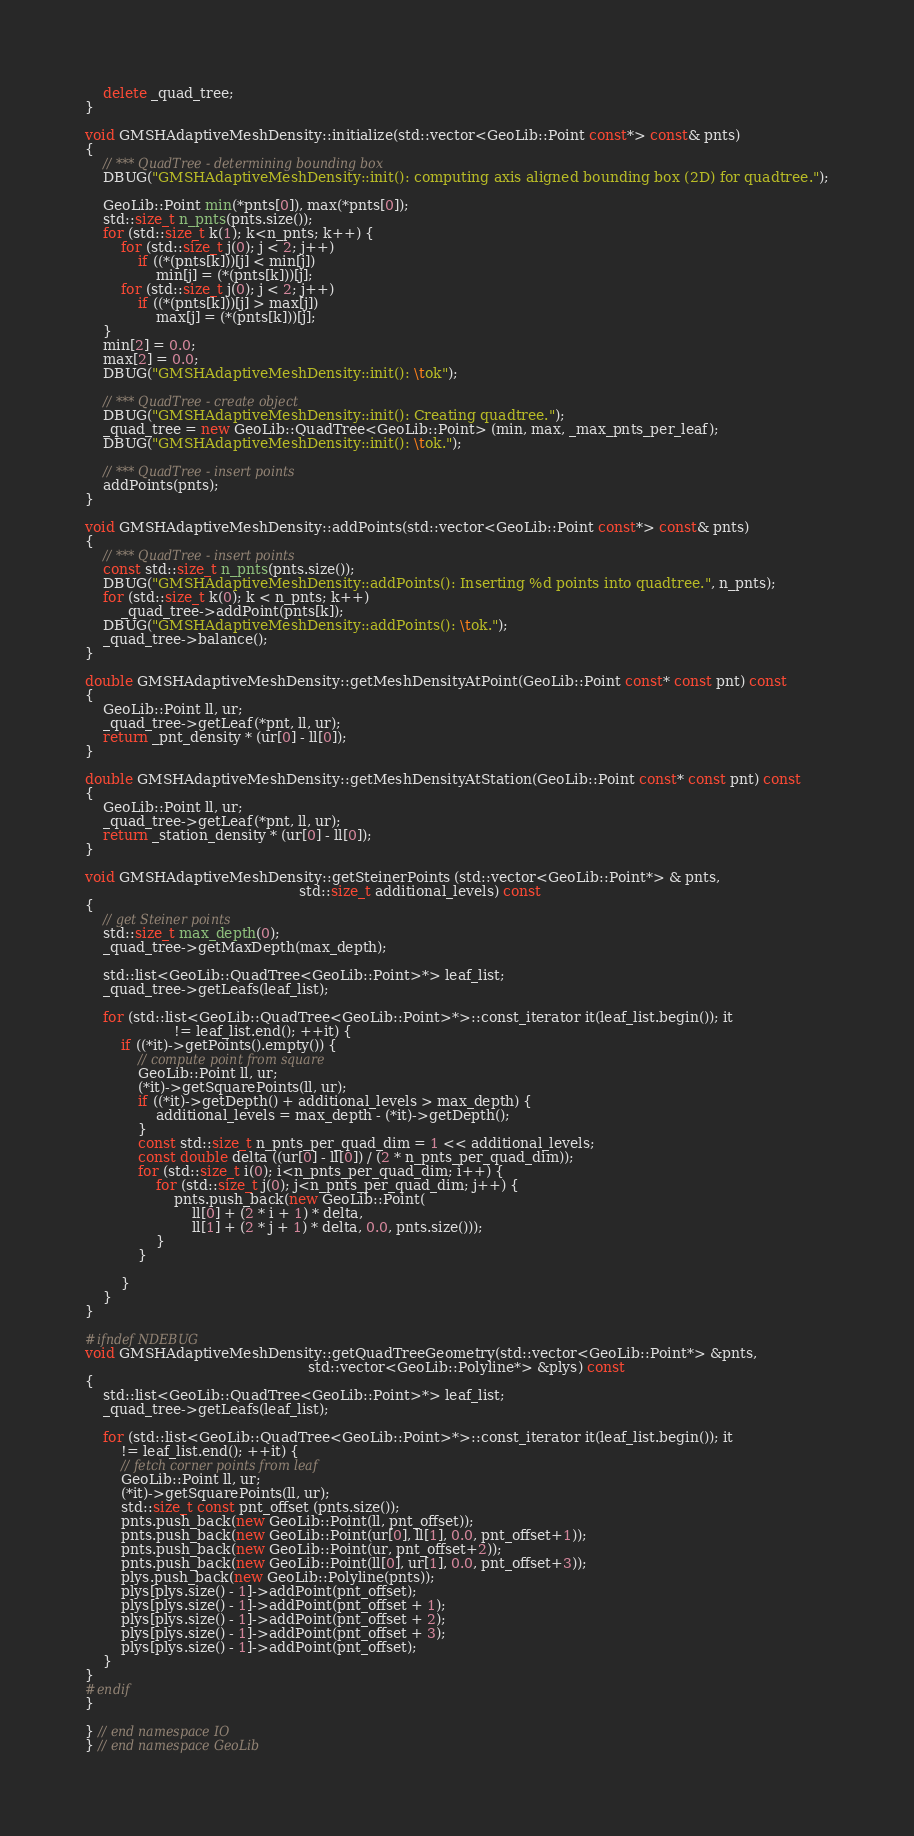Convert code to text. <code><loc_0><loc_0><loc_500><loc_500><_C++_>    delete _quad_tree;
}

void GMSHAdaptiveMeshDensity::initialize(std::vector<GeoLib::Point const*> const& pnts)
{
    // *** QuadTree - determining bounding box
    DBUG("GMSHAdaptiveMeshDensity::init(): computing axis aligned bounding box (2D) for quadtree.");

    GeoLib::Point min(*pnts[0]), max(*pnts[0]);
    std::size_t n_pnts(pnts.size());
    for (std::size_t k(1); k<n_pnts; k++) {
        for (std::size_t j(0); j < 2; j++)
            if ((*(pnts[k]))[j] < min[j])
                min[j] = (*(pnts[k]))[j];
        for (std::size_t j(0); j < 2; j++)
            if ((*(pnts[k]))[j] > max[j])
                max[j] = (*(pnts[k]))[j];
    }
    min[2] = 0.0;
    max[2] = 0.0;
    DBUG("GMSHAdaptiveMeshDensity::init(): \tok");

    // *** QuadTree - create object
    DBUG("GMSHAdaptiveMeshDensity::init(): Creating quadtree.");
    _quad_tree = new GeoLib::QuadTree<GeoLib::Point> (min, max, _max_pnts_per_leaf);
    DBUG("GMSHAdaptiveMeshDensity::init(): \tok.");

    // *** QuadTree - insert points
    addPoints(pnts);
}

void GMSHAdaptiveMeshDensity::addPoints(std::vector<GeoLib::Point const*> const& pnts)
{
    // *** QuadTree - insert points
    const std::size_t n_pnts(pnts.size());
    DBUG("GMSHAdaptiveMeshDensity::addPoints(): Inserting %d points into quadtree.", n_pnts);
    for (std::size_t k(0); k < n_pnts; k++)
        _quad_tree->addPoint(pnts[k]);
    DBUG("GMSHAdaptiveMeshDensity::addPoints(): \tok.");
    _quad_tree->balance();
}

double GMSHAdaptiveMeshDensity::getMeshDensityAtPoint(GeoLib::Point const* const pnt) const
{
    GeoLib::Point ll, ur;
    _quad_tree->getLeaf(*pnt, ll, ur);
    return _pnt_density * (ur[0] - ll[0]);
}

double GMSHAdaptiveMeshDensity::getMeshDensityAtStation(GeoLib::Point const* const pnt) const
{
    GeoLib::Point ll, ur;
    _quad_tree->getLeaf(*pnt, ll, ur);
    return _station_density * (ur[0] - ll[0]);
}

void GMSHAdaptiveMeshDensity::getSteinerPoints (std::vector<GeoLib::Point*> & pnts,
                                                std::size_t additional_levels) const
{
    // get Steiner points
    std::size_t max_depth(0);
    _quad_tree->getMaxDepth(max_depth);

    std::list<GeoLib::QuadTree<GeoLib::Point>*> leaf_list;
    _quad_tree->getLeafs(leaf_list);

    for (std::list<GeoLib::QuadTree<GeoLib::Point>*>::const_iterator it(leaf_list.begin()); it
                    != leaf_list.end(); ++it) {
        if ((*it)->getPoints().empty()) {
            // compute point from square
            GeoLib::Point ll, ur;
            (*it)->getSquarePoints(ll, ur);
            if ((*it)->getDepth() + additional_levels > max_depth) {
                additional_levels = max_depth - (*it)->getDepth();
            }
            const std::size_t n_pnts_per_quad_dim = 1 << additional_levels;
            const double delta ((ur[0] - ll[0]) / (2 * n_pnts_per_quad_dim));
            for (std::size_t i(0); i<n_pnts_per_quad_dim; i++) {
                for (std::size_t j(0); j<n_pnts_per_quad_dim; j++) {
                    pnts.push_back(new GeoLib::Point(
                        ll[0] + (2 * i + 1) * delta,
                        ll[1] + (2 * j + 1) * delta, 0.0, pnts.size()));
                }
            }

        }
    }
}

#ifndef NDEBUG
void GMSHAdaptiveMeshDensity::getQuadTreeGeometry(std::vector<GeoLib::Point*> &pnts,
                                                  std::vector<GeoLib::Polyline*> &plys) const
{
    std::list<GeoLib::QuadTree<GeoLib::Point>*> leaf_list;
    _quad_tree->getLeafs(leaf_list);

    for (std::list<GeoLib::QuadTree<GeoLib::Point>*>::const_iterator it(leaf_list.begin()); it
        != leaf_list.end(); ++it) {
        // fetch corner points from leaf
        GeoLib::Point ll, ur;
        (*it)->getSquarePoints(ll, ur);
        std::size_t const pnt_offset (pnts.size());
        pnts.push_back(new GeoLib::Point(ll, pnt_offset));
        pnts.push_back(new GeoLib::Point(ur[0], ll[1], 0.0, pnt_offset+1));
        pnts.push_back(new GeoLib::Point(ur, pnt_offset+2));
        pnts.push_back(new GeoLib::Point(ll[0], ur[1], 0.0, pnt_offset+3));
        plys.push_back(new GeoLib::Polyline(pnts));
        plys[plys.size() - 1]->addPoint(pnt_offset);
        plys[plys.size() - 1]->addPoint(pnt_offset + 1);
        plys[plys.size() - 1]->addPoint(pnt_offset + 2);
        plys[plys.size() - 1]->addPoint(pnt_offset + 3);
        plys[plys.size() - 1]->addPoint(pnt_offset);
    }
}
#endif
}

} // end namespace IO
} // end namespace GeoLib
</code> 